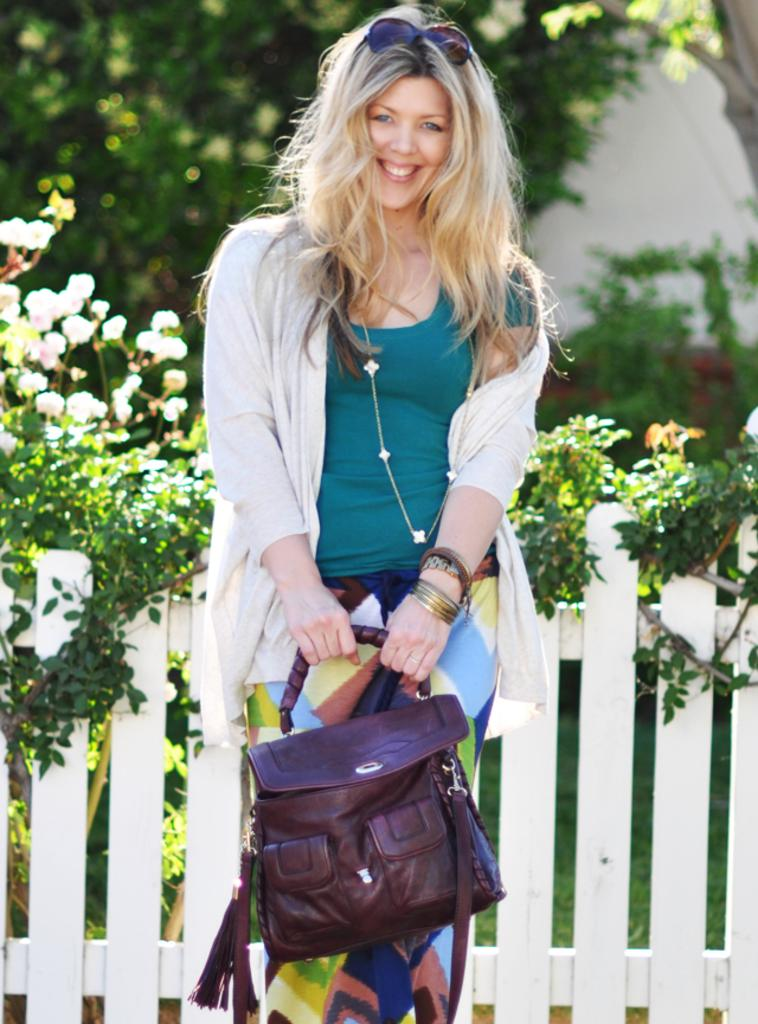Who is present in the image? There is a woman in the image. What is the woman doing in the image? The woman is standing in the image. What is the woman holding in the image? The woman is holding a bag in the image. What type of fruit can be seen growing in the field behind the woman? There is no field or fruit visible in the image; it only features a woman standing and holding a bag. 